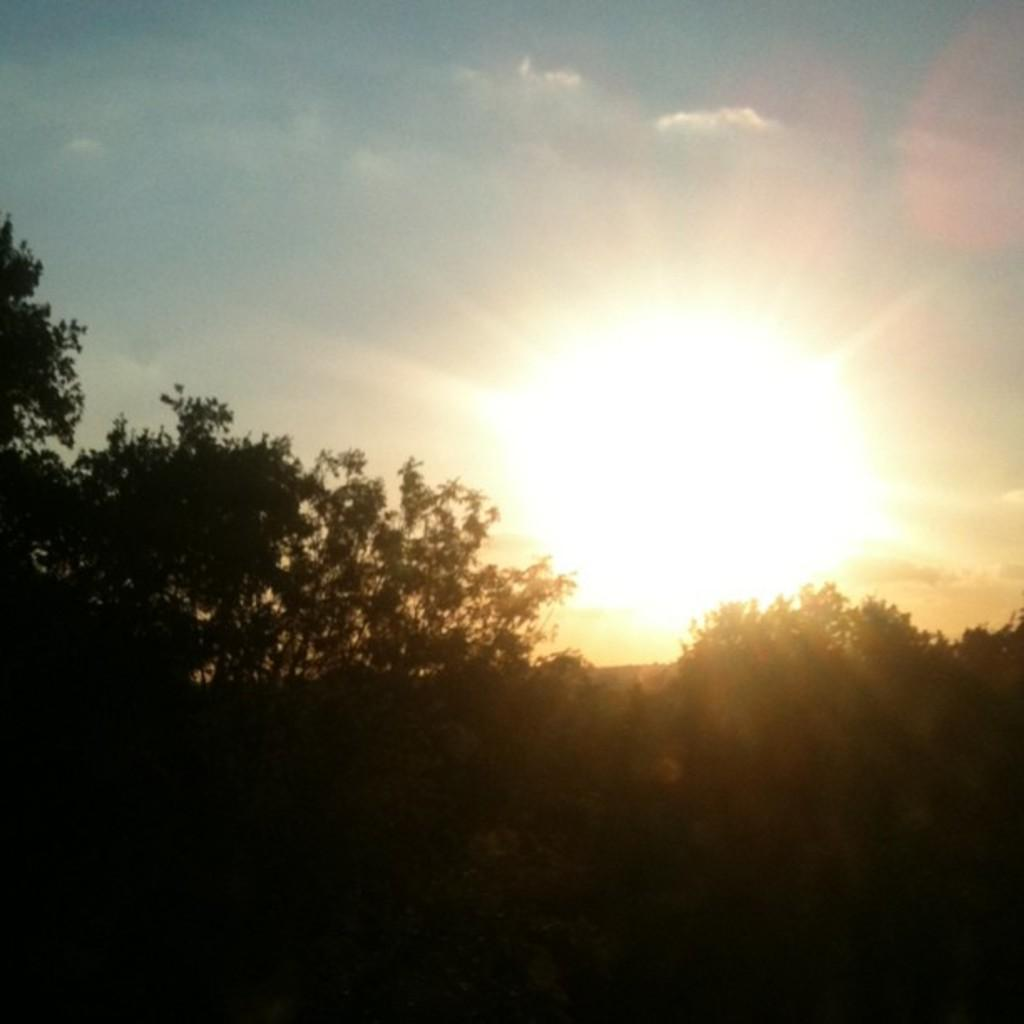What type of vegetation can be seen in the image? There are many trees in the image. What is visible in the background of the image? There is a sky visible in the image. Can the sun be seen in the image? Yes, there is a sun visible in the image. What type of steam can be seen coming from the trees in the image? There is no steam visible in the image; it only features trees, sky, and the sun. 